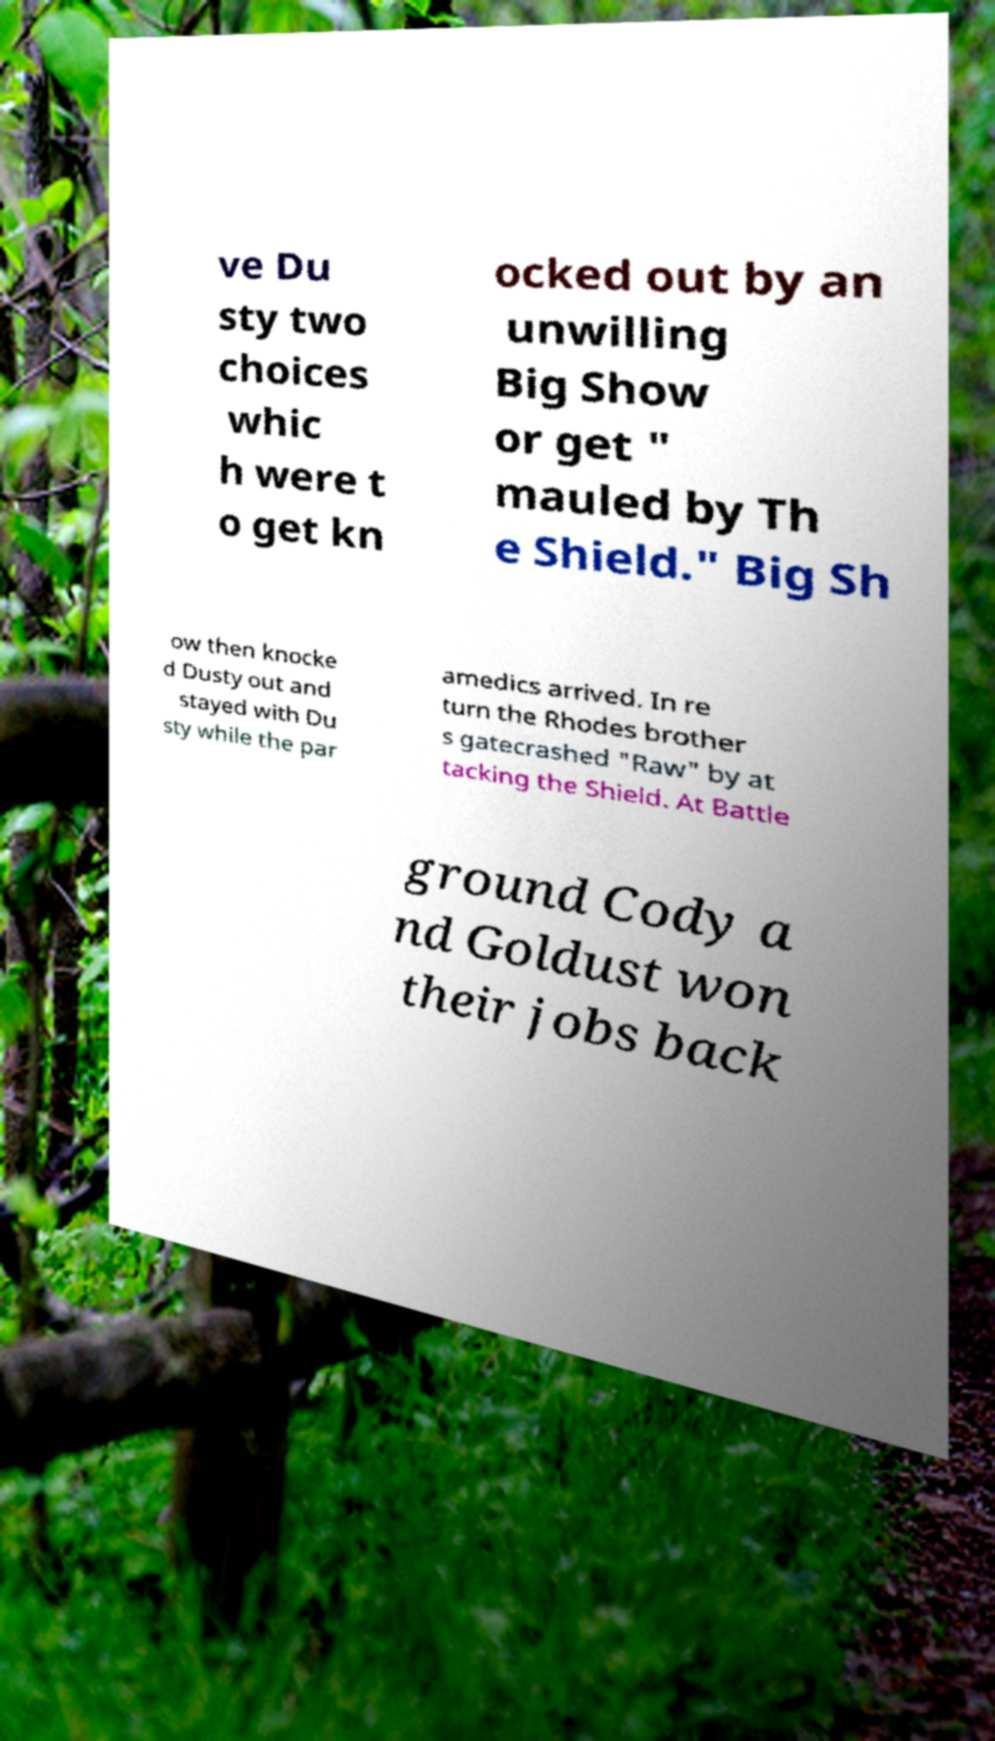Can you read and provide the text displayed in the image?This photo seems to have some interesting text. Can you extract and type it out for me? ve Du sty two choices whic h were t o get kn ocked out by an unwilling Big Show or get " mauled by Th e Shield." Big Sh ow then knocke d Dusty out and stayed with Du sty while the par amedics arrived. In re turn the Rhodes brother s gatecrashed "Raw" by at tacking the Shield. At Battle ground Cody a nd Goldust won their jobs back 